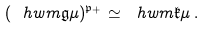Convert formula to latex. <formula><loc_0><loc_0><loc_500><loc_500>( \ h w m { \mathfrak { g } } { \mu } ) ^ { \mathfrak { p } _ { + } } \simeq \ h w m { \mathfrak { k } } { \mu } \, .</formula> 